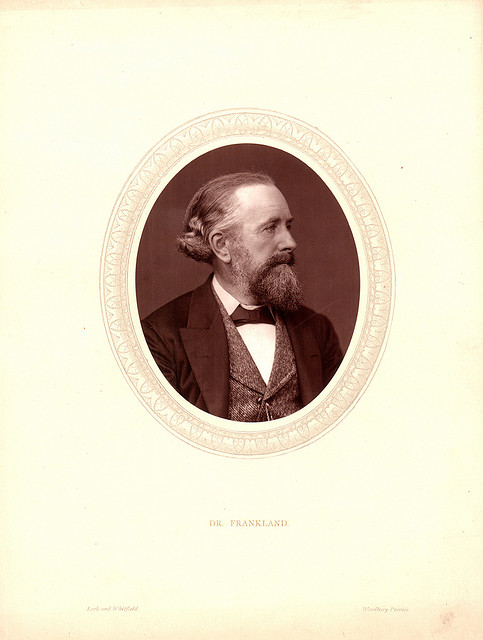Identify the text displayed in this image. FRANKLAND 